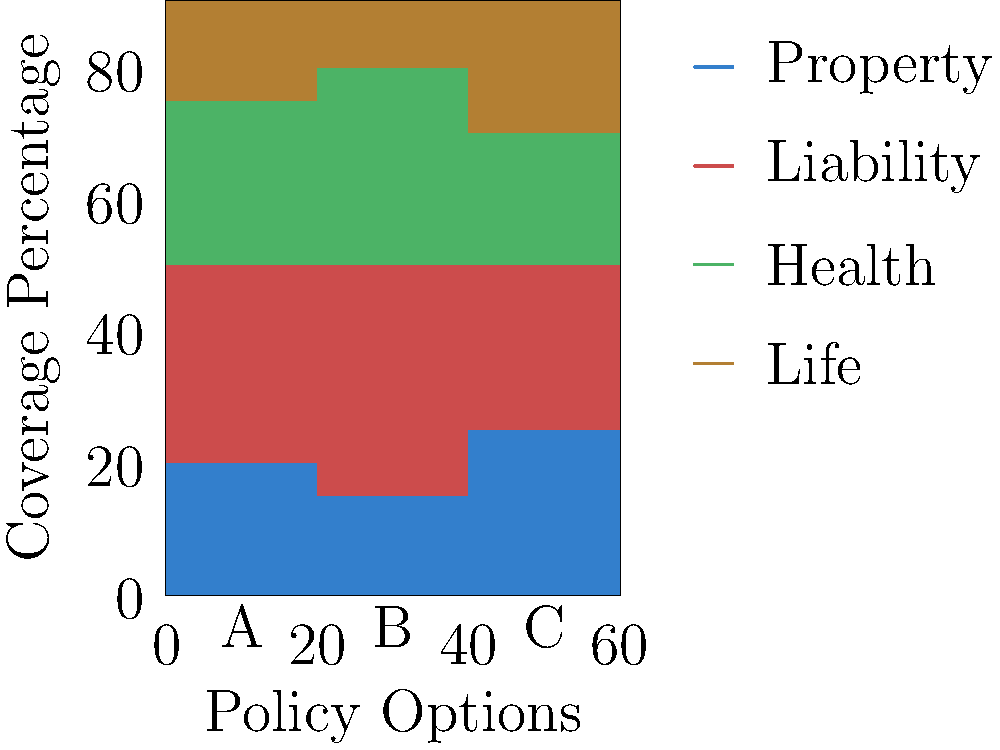Based on the stacked bar chart comparing three insurance policy options (A, B, and C), which policy offers the highest percentage of coverage for property insurance? To determine which policy offers the highest percentage of coverage for property insurance, we need to examine the bottom segment of each stacked bar, as this represents the property insurance coverage for each policy option.

Step 1: Identify the property insurance segment for each policy.
- The property insurance segment is represented by the blue color at the bottom of each bar.

Step 2: Compare the heights of the blue segments across all three policies.
- Policy A: The blue segment covers approximately 20% of the total bar height.
- Policy B: The blue segment covers approximately 15% of the total bar height.
- Policy C: The blue segment covers approximately 25% of the total bar height.

Step 3: Determine which policy has the tallest blue segment.
- Policy C has the tallest blue segment, indicating the highest percentage of coverage for property insurance.

Therefore, Policy C offers the highest percentage of coverage for property insurance among the three options presented.
Answer: Policy C 